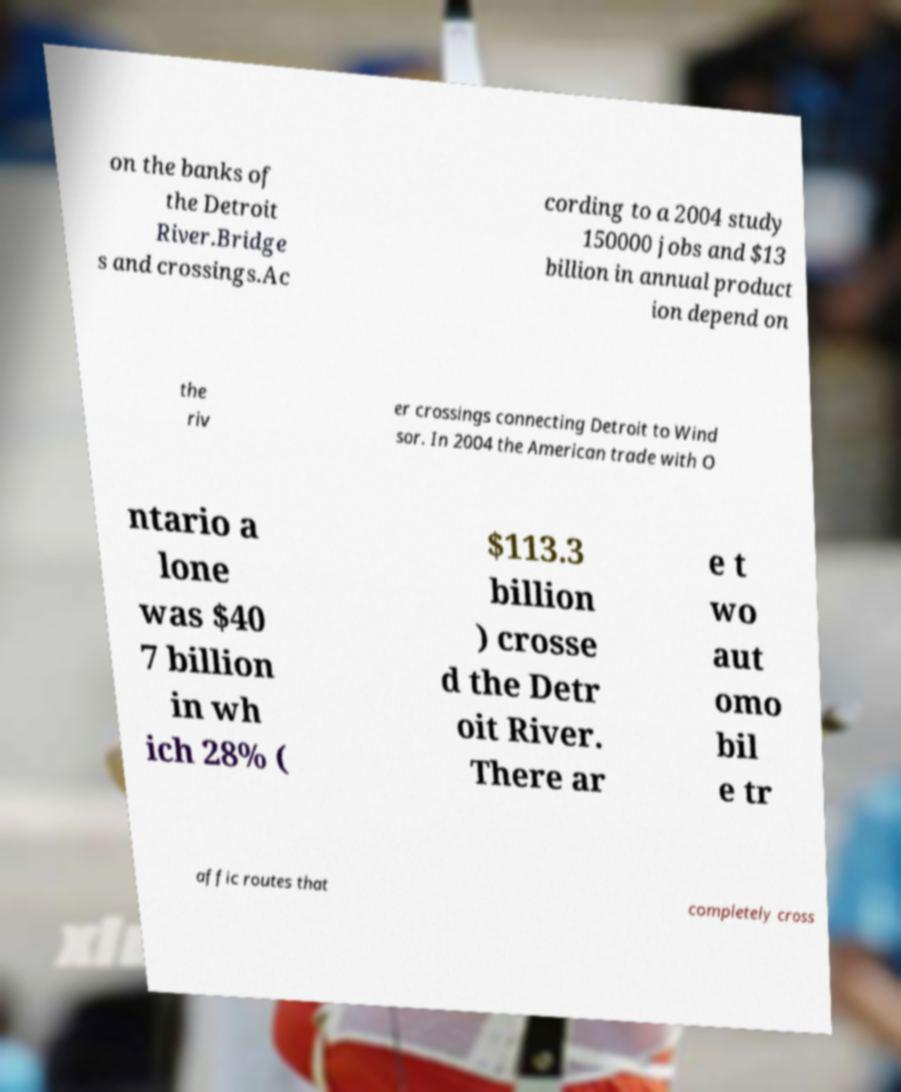Could you assist in decoding the text presented in this image and type it out clearly? on the banks of the Detroit River.Bridge s and crossings.Ac cording to a 2004 study 150000 jobs and $13 billion in annual product ion depend on the riv er crossings connecting Detroit to Wind sor. In 2004 the American trade with O ntario a lone was $40 7 billion in wh ich 28% ( $113.3 billion ) crosse d the Detr oit River. There ar e t wo aut omo bil e tr affic routes that completely cross 